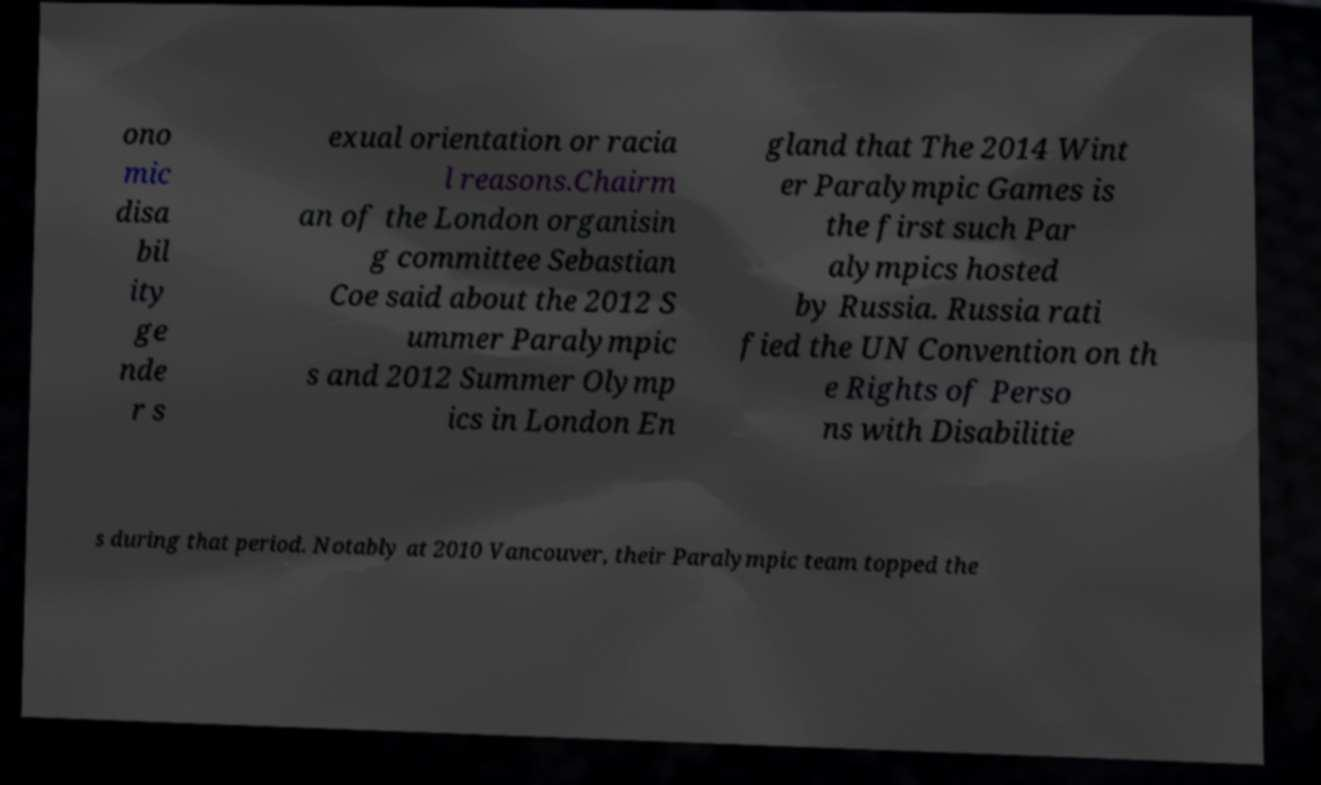Please read and relay the text visible in this image. What does it say? ono mic disa bil ity ge nde r s exual orientation or racia l reasons.Chairm an of the London organisin g committee Sebastian Coe said about the 2012 S ummer Paralympic s and 2012 Summer Olymp ics in London En gland that The 2014 Wint er Paralympic Games is the first such Par alympics hosted by Russia. Russia rati fied the UN Convention on th e Rights of Perso ns with Disabilitie s during that period. Notably at 2010 Vancouver, their Paralympic team topped the 